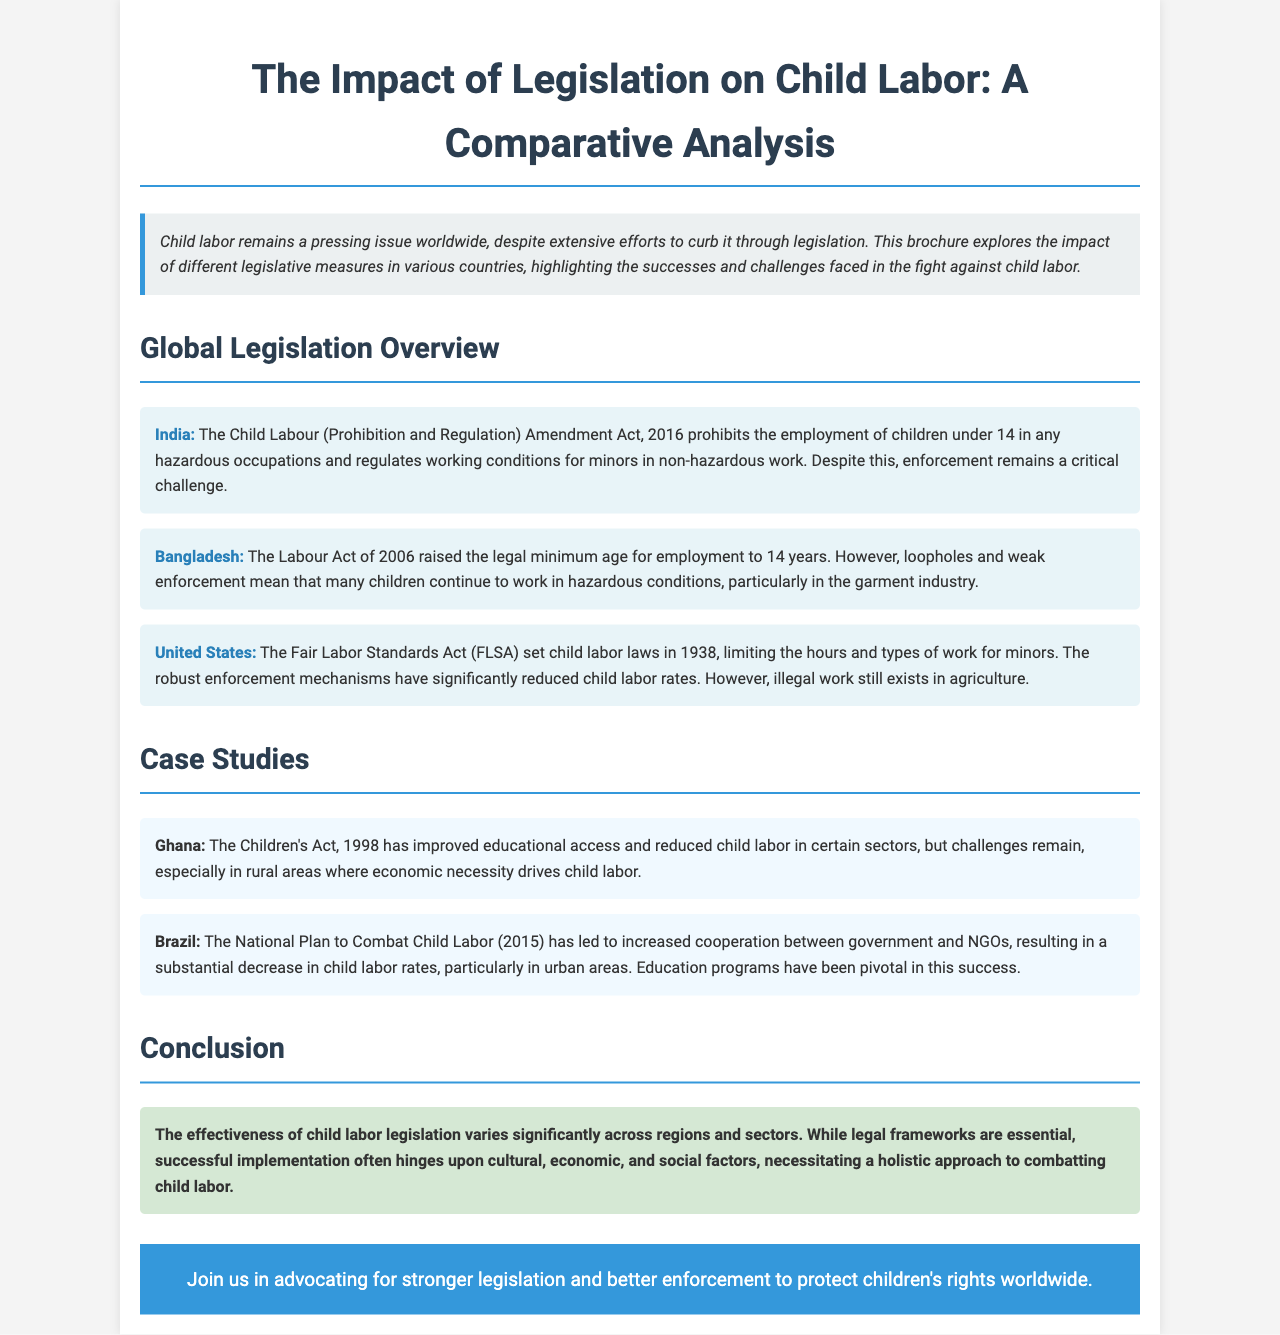what is the title of the document? The title of the document is displayed prominently at the top of the page, stating its focus.
Answer: The Impact of Legislation on Child Labor: A Comparative Analysis what year was the Child Labour (Prohibition and Regulation) Amendment Act enacted in India? The document mentions the specific amendment and its year in the context of India's legislation.
Answer: 2016 which country implemented the National Plan to Combat Child Labor in 2015? The text within the case studies section identifies the country associated with this specific plan.
Answer: Brazil what act did the United States establish in 1938 to regulate child labor? The document refers to this historical legislation that set child labor laws.
Answer: Fair Labor Standards Act what does the Children’s Act, 1998 aim to improve in Ghana? The document highlights the positive impact of this legislation in relation to child labor in Ghana.
Answer: Educational access what is the primary challenge mentioned regarding child labor in Bangladesh? The document highlights a key issue that persists despite legal changes.
Answer: Weak enforcement which country has a case study discussing the reduction of child labor particularly in urban areas? The case studies provide insights into a country where a decrease in child labor has been reported.
Answer: Brazil what is emphasized as necessary for effective child labor legislation? The conclusion of the brochure points out critical factors that influence implementation success.
Answer: Holistic approach 